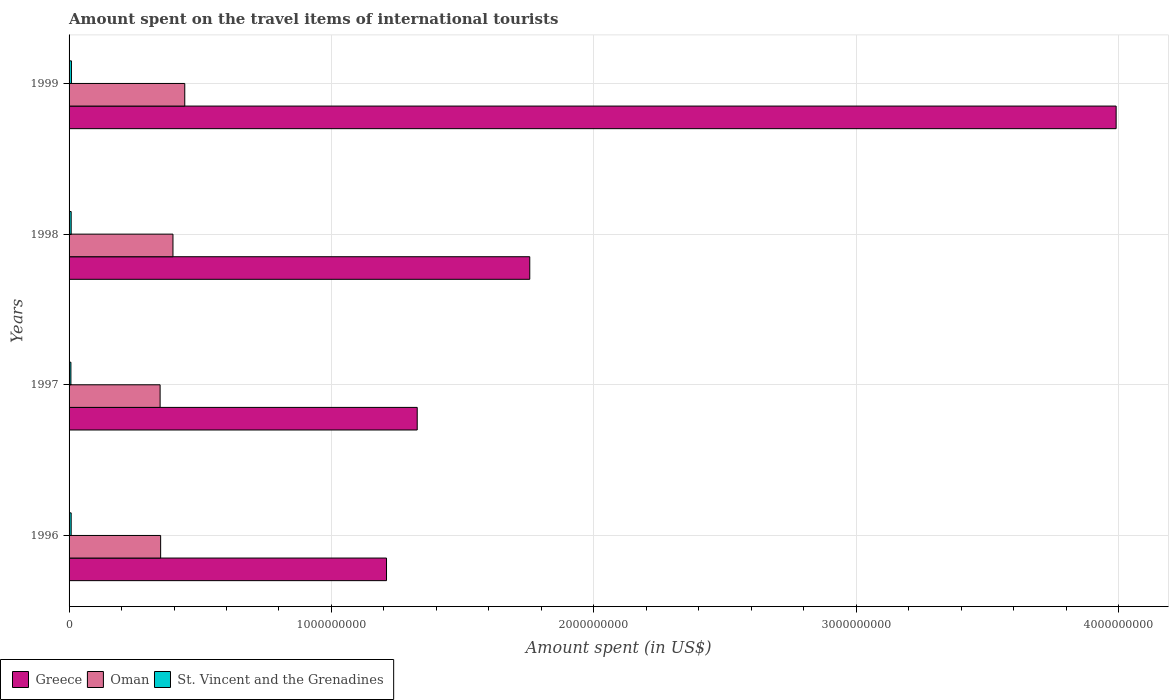How many groups of bars are there?
Ensure brevity in your answer.  4. Are the number of bars per tick equal to the number of legend labels?
Your answer should be very brief. Yes. Are the number of bars on each tick of the Y-axis equal?
Provide a short and direct response. Yes. How many bars are there on the 3rd tick from the top?
Keep it short and to the point. 3. How many bars are there on the 3rd tick from the bottom?
Provide a succinct answer. 3. What is the label of the 2nd group of bars from the top?
Keep it short and to the point. 1998. What is the amount spent on the travel items of international tourists in Oman in 1998?
Give a very brief answer. 3.96e+08. Across all years, what is the maximum amount spent on the travel items of international tourists in Oman?
Your answer should be very brief. 4.41e+08. Across all years, what is the minimum amount spent on the travel items of international tourists in Greece?
Your response must be concise. 1.21e+09. In which year was the amount spent on the travel items of international tourists in Oman maximum?
Offer a terse response. 1999. What is the total amount spent on the travel items of international tourists in Greece in the graph?
Your response must be concise. 8.28e+09. What is the difference between the amount spent on the travel items of international tourists in St. Vincent and the Grenadines in 1996 and that in 1997?
Your answer should be very brief. 1.00e+06. What is the difference between the amount spent on the travel items of international tourists in Greece in 1996 and the amount spent on the travel items of international tourists in St. Vincent and the Grenadines in 1999?
Offer a very short reply. 1.20e+09. What is the average amount spent on the travel items of international tourists in Oman per year?
Your answer should be very brief. 3.83e+08. In the year 1998, what is the difference between the amount spent on the travel items of international tourists in St. Vincent and the Grenadines and amount spent on the travel items of international tourists in Greece?
Offer a terse response. -1.75e+09. What is the ratio of the amount spent on the travel items of international tourists in Oman in 1997 to that in 1999?
Ensure brevity in your answer.  0.79. What is the difference between the highest and the lowest amount spent on the travel items of international tourists in Greece?
Offer a very short reply. 2.78e+09. Is the sum of the amount spent on the travel items of international tourists in Oman in 1997 and 1998 greater than the maximum amount spent on the travel items of international tourists in St. Vincent and the Grenadines across all years?
Ensure brevity in your answer.  Yes. What does the 2nd bar from the top in 1997 represents?
Your answer should be compact. Oman. What does the 2nd bar from the bottom in 1999 represents?
Give a very brief answer. Oman. Is it the case that in every year, the sum of the amount spent on the travel items of international tourists in Oman and amount spent on the travel items of international tourists in Greece is greater than the amount spent on the travel items of international tourists in St. Vincent and the Grenadines?
Make the answer very short. Yes. How many bars are there?
Your answer should be very brief. 12. Are all the bars in the graph horizontal?
Give a very brief answer. Yes. Are the values on the major ticks of X-axis written in scientific E-notation?
Provide a succinct answer. No. Does the graph contain any zero values?
Give a very brief answer. No. Does the graph contain grids?
Your response must be concise. Yes. How many legend labels are there?
Provide a succinct answer. 3. What is the title of the graph?
Provide a short and direct response. Amount spent on the travel items of international tourists. Does "Iraq" appear as one of the legend labels in the graph?
Give a very brief answer. No. What is the label or title of the X-axis?
Make the answer very short. Amount spent (in US$). What is the Amount spent (in US$) of Greece in 1996?
Your answer should be compact. 1.21e+09. What is the Amount spent (in US$) of Oman in 1996?
Keep it short and to the point. 3.49e+08. What is the Amount spent (in US$) in St. Vincent and the Grenadines in 1996?
Your response must be concise. 8.00e+06. What is the Amount spent (in US$) in Greece in 1997?
Offer a terse response. 1.33e+09. What is the Amount spent (in US$) in Oman in 1997?
Ensure brevity in your answer.  3.47e+08. What is the Amount spent (in US$) in St. Vincent and the Grenadines in 1997?
Your response must be concise. 7.00e+06. What is the Amount spent (in US$) in Greece in 1998?
Your answer should be compact. 1.76e+09. What is the Amount spent (in US$) in Oman in 1998?
Ensure brevity in your answer.  3.96e+08. What is the Amount spent (in US$) in Greece in 1999?
Ensure brevity in your answer.  3.99e+09. What is the Amount spent (in US$) of Oman in 1999?
Give a very brief answer. 4.41e+08. What is the Amount spent (in US$) of St. Vincent and the Grenadines in 1999?
Ensure brevity in your answer.  9.00e+06. Across all years, what is the maximum Amount spent (in US$) of Greece?
Your response must be concise. 3.99e+09. Across all years, what is the maximum Amount spent (in US$) in Oman?
Provide a short and direct response. 4.41e+08. Across all years, what is the maximum Amount spent (in US$) of St. Vincent and the Grenadines?
Offer a terse response. 9.00e+06. Across all years, what is the minimum Amount spent (in US$) in Greece?
Offer a terse response. 1.21e+09. Across all years, what is the minimum Amount spent (in US$) of Oman?
Offer a very short reply. 3.47e+08. Across all years, what is the minimum Amount spent (in US$) of St. Vincent and the Grenadines?
Keep it short and to the point. 7.00e+06. What is the total Amount spent (in US$) in Greece in the graph?
Ensure brevity in your answer.  8.28e+09. What is the total Amount spent (in US$) in Oman in the graph?
Make the answer very short. 1.53e+09. What is the total Amount spent (in US$) of St. Vincent and the Grenadines in the graph?
Offer a very short reply. 3.20e+07. What is the difference between the Amount spent (in US$) of Greece in 1996 and that in 1997?
Offer a very short reply. -1.17e+08. What is the difference between the Amount spent (in US$) of Greece in 1996 and that in 1998?
Give a very brief answer. -5.46e+08. What is the difference between the Amount spent (in US$) in Oman in 1996 and that in 1998?
Your answer should be compact. -4.70e+07. What is the difference between the Amount spent (in US$) of St. Vincent and the Grenadines in 1996 and that in 1998?
Your response must be concise. 0. What is the difference between the Amount spent (in US$) in Greece in 1996 and that in 1999?
Offer a very short reply. -2.78e+09. What is the difference between the Amount spent (in US$) of Oman in 1996 and that in 1999?
Provide a succinct answer. -9.20e+07. What is the difference between the Amount spent (in US$) of Greece in 1997 and that in 1998?
Your answer should be very brief. -4.29e+08. What is the difference between the Amount spent (in US$) in Oman in 1997 and that in 1998?
Make the answer very short. -4.90e+07. What is the difference between the Amount spent (in US$) of Greece in 1997 and that in 1999?
Provide a succinct answer. -2.66e+09. What is the difference between the Amount spent (in US$) in Oman in 1997 and that in 1999?
Ensure brevity in your answer.  -9.40e+07. What is the difference between the Amount spent (in US$) in St. Vincent and the Grenadines in 1997 and that in 1999?
Your response must be concise. -2.00e+06. What is the difference between the Amount spent (in US$) in Greece in 1998 and that in 1999?
Provide a short and direct response. -2.24e+09. What is the difference between the Amount spent (in US$) of Oman in 1998 and that in 1999?
Your response must be concise. -4.50e+07. What is the difference between the Amount spent (in US$) in Greece in 1996 and the Amount spent (in US$) in Oman in 1997?
Give a very brief answer. 8.63e+08. What is the difference between the Amount spent (in US$) of Greece in 1996 and the Amount spent (in US$) of St. Vincent and the Grenadines in 1997?
Your answer should be compact. 1.20e+09. What is the difference between the Amount spent (in US$) in Oman in 1996 and the Amount spent (in US$) in St. Vincent and the Grenadines in 1997?
Give a very brief answer. 3.42e+08. What is the difference between the Amount spent (in US$) of Greece in 1996 and the Amount spent (in US$) of Oman in 1998?
Ensure brevity in your answer.  8.14e+08. What is the difference between the Amount spent (in US$) in Greece in 1996 and the Amount spent (in US$) in St. Vincent and the Grenadines in 1998?
Make the answer very short. 1.20e+09. What is the difference between the Amount spent (in US$) in Oman in 1996 and the Amount spent (in US$) in St. Vincent and the Grenadines in 1998?
Your answer should be very brief. 3.41e+08. What is the difference between the Amount spent (in US$) in Greece in 1996 and the Amount spent (in US$) in Oman in 1999?
Provide a short and direct response. 7.69e+08. What is the difference between the Amount spent (in US$) of Greece in 1996 and the Amount spent (in US$) of St. Vincent and the Grenadines in 1999?
Offer a very short reply. 1.20e+09. What is the difference between the Amount spent (in US$) of Oman in 1996 and the Amount spent (in US$) of St. Vincent and the Grenadines in 1999?
Keep it short and to the point. 3.40e+08. What is the difference between the Amount spent (in US$) in Greece in 1997 and the Amount spent (in US$) in Oman in 1998?
Offer a terse response. 9.31e+08. What is the difference between the Amount spent (in US$) in Greece in 1997 and the Amount spent (in US$) in St. Vincent and the Grenadines in 1998?
Provide a short and direct response. 1.32e+09. What is the difference between the Amount spent (in US$) of Oman in 1997 and the Amount spent (in US$) of St. Vincent and the Grenadines in 1998?
Ensure brevity in your answer.  3.39e+08. What is the difference between the Amount spent (in US$) in Greece in 1997 and the Amount spent (in US$) in Oman in 1999?
Your answer should be very brief. 8.86e+08. What is the difference between the Amount spent (in US$) in Greece in 1997 and the Amount spent (in US$) in St. Vincent and the Grenadines in 1999?
Provide a short and direct response. 1.32e+09. What is the difference between the Amount spent (in US$) of Oman in 1997 and the Amount spent (in US$) of St. Vincent and the Grenadines in 1999?
Your response must be concise. 3.38e+08. What is the difference between the Amount spent (in US$) of Greece in 1998 and the Amount spent (in US$) of Oman in 1999?
Make the answer very short. 1.32e+09. What is the difference between the Amount spent (in US$) of Greece in 1998 and the Amount spent (in US$) of St. Vincent and the Grenadines in 1999?
Offer a terse response. 1.75e+09. What is the difference between the Amount spent (in US$) in Oman in 1998 and the Amount spent (in US$) in St. Vincent and the Grenadines in 1999?
Your answer should be very brief. 3.87e+08. What is the average Amount spent (in US$) in Greece per year?
Provide a succinct answer. 2.07e+09. What is the average Amount spent (in US$) in Oman per year?
Your response must be concise. 3.83e+08. In the year 1996, what is the difference between the Amount spent (in US$) in Greece and Amount spent (in US$) in Oman?
Your answer should be compact. 8.61e+08. In the year 1996, what is the difference between the Amount spent (in US$) of Greece and Amount spent (in US$) of St. Vincent and the Grenadines?
Provide a succinct answer. 1.20e+09. In the year 1996, what is the difference between the Amount spent (in US$) in Oman and Amount spent (in US$) in St. Vincent and the Grenadines?
Provide a succinct answer. 3.41e+08. In the year 1997, what is the difference between the Amount spent (in US$) in Greece and Amount spent (in US$) in Oman?
Your answer should be compact. 9.80e+08. In the year 1997, what is the difference between the Amount spent (in US$) in Greece and Amount spent (in US$) in St. Vincent and the Grenadines?
Your answer should be very brief. 1.32e+09. In the year 1997, what is the difference between the Amount spent (in US$) in Oman and Amount spent (in US$) in St. Vincent and the Grenadines?
Keep it short and to the point. 3.40e+08. In the year 1998, what is the difference between the Amount spent (in US$) in Greece and Amount spent (in US$) in Oman?
Make the answer very short. 1.36e+09. In the year 1998, what is the difference between the Amount spent (in US$) in Greece and Amount spent (in US$) in St. Vincent and the Grenadines?
Provide a short and direct response. 1.75e+09. In the year 1998, what is the difference between the Amount spent (in US$) of Oman and Amount spent (in US$) of St. Vincent and the Grenadines?
Give a very brief answer. 3.88e+08. In the year 1999, what is the difference between the Amount spent (in US$) in Greece and Amount spent (in US$) in Oman?
Provide a short and direct response. 3.55e+09. In the year 1999, what is the difference between the Amount spent (in US$) of Greece and Amount spent (in US$) of St. Vincent and the Grenadines?
Your answer should be compact. 3.98e+09. In the year 1999, what is the difference between the Amount spent (in US$) of Oman and Amount spent (in US$) of St. Vincent and the Grenadines?
Provide a succinct answer. 4.32e+08. What is the ratio of the Amount spent (in US$) in Greece in 1996 to that in 1997?
Your answer should be compact. 0.91. What is the ratio of the Amount spent (in US$) in St. Vincent and the Grenadines in 1996 to that in 1997?
Give a very brief answer. 1.14. What is the ratio of the Amount spent (in US$) of Greece in 1996 to that in 1998?
Keep it short and to the point. 0.69. What is the ratio of the Amount spent (in US$) in Oman in 1996 to that in 1998?
Give a very brief answer. 0.88. What is the ratio of the Amount spent (in US$) in St. Vincent and the Grenadines in 1996 to that in 1998?
Provide a succinct answer. 1. What is the ratio of the Amount spent (in US$) of Greece in 1996 to that in 1999?
Give a very brief answer. 0.3. What is the ratio of the Amount spent (in US$) in Oman in 1996 to that in 1999?
Give a very brief answer. 0.79. What is the ratio of the Amount spent (in US$) in St. Vincent and the Grenadines in 1996 to that in 1999?
Offer a very short reply. 0.89. What is the ratio of the Amount spent (in US$) in Greece in 1997 to that in 1998?
Offer a very short reply. 0.76. What is the ratio of the Amount spent (in US$) of Oman in 1997 to that in 1998?
Give a very brief answer. 0.88. What is the ratio of the Amount spent (in US$) in Greece in 1997 to that in 1999?
Provide a succinct answer. 0.33. What is the ratio of the Amount spent (in US$) of Oman in 1997 to that in 1999?
Keep it short and to the point. 0.79. What is the ratio of the Amount spent (in US$) of St. Vincent and the Grenadines in 1997 to that in 1999?
Ensure brevity in your answer.  0.78. What is the ratio of the Amount spent (in US$) of Greece in 1998 to that in 1999?
Offer a very short reply. 0.44. What is the ratio of the Amount spent (in US$) of Oman in 1998 to that in 1999?
Your response must be concise. 0.9. What is the ratio of the Amount spent (in US$) in St. Vincent and the Grenadines in 1998 to that in 1999?
Keep it short and to the point. 0.89. What is the difference between the highest and the second highest Amount spent (in US$) in Greece?
Your answer should be very brief. 2.24e+09. What is the difference between the highest and the second highest Amount spent (in US$) in Oman?
Provide a short and direct response. 4.50e+07. What is the difference between the highest and the lowest Amount spent (in US$) of Greece?
Provide a short and direct response. 2.78e+09. What is the difference between the highest and the lowest Amount spent (in US$) of Oman?
Offer a terse response. 9.40e+07. 